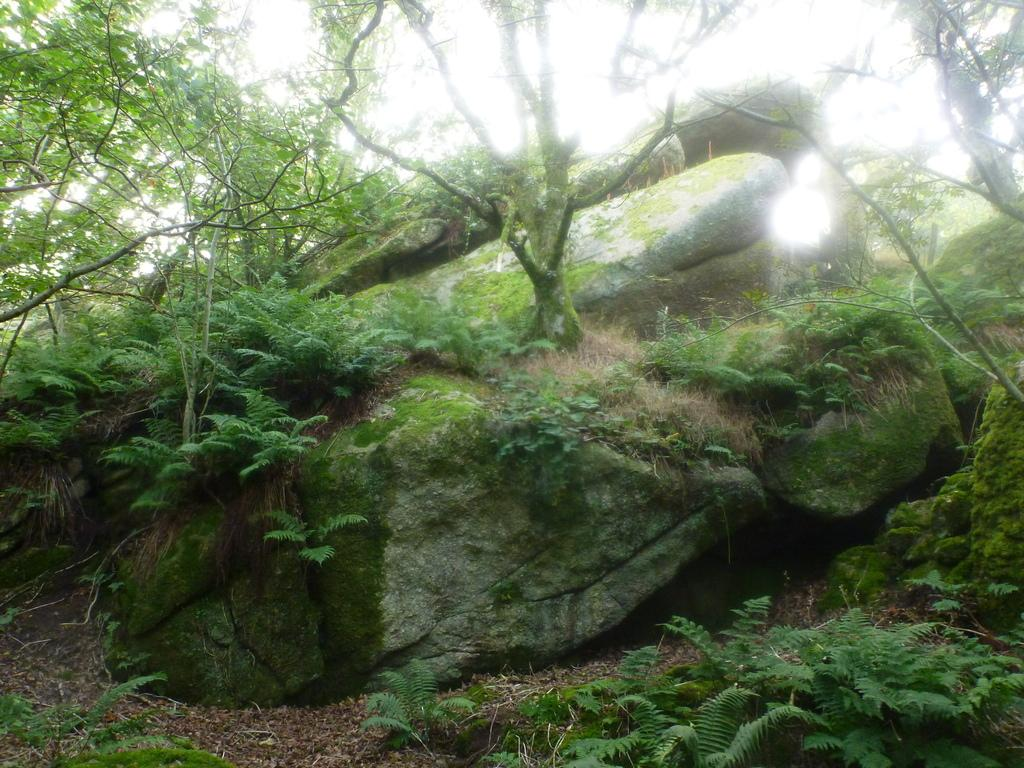What type of natural elements can be seen in the image? There are rocks, trees, and plants visible in the image. Can you describe the rocks in the image? The rocks are present in the image, but no specific details about their size, shape, or color are provided. What type of vegetation is present in the image? Trees and plants can be seen in the image. Where is the swing located in the image? There is no swing present in the image. What type of education can be seen in the image? There is no reference to education in the image; it features rocks, trees, and plants. 